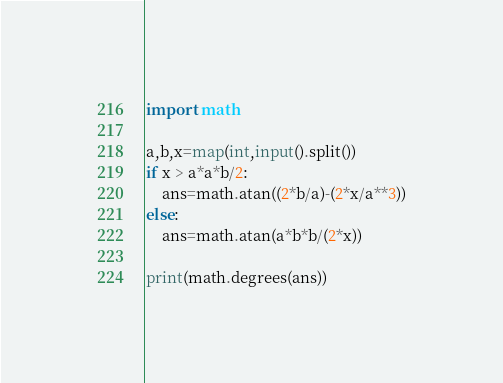Convert code to text. <code><loc_0><loc_0><loc_500><loc_500><_Python_>import math

a,b,x=map(int,input().split())
if x > a*a*b/2:
    ans=math.atan((2*b/a)-(2*x/a**3))
else:
    ans=math.atan(a*b*b/(2*x))

print(math.degrees(ans))


</code> 